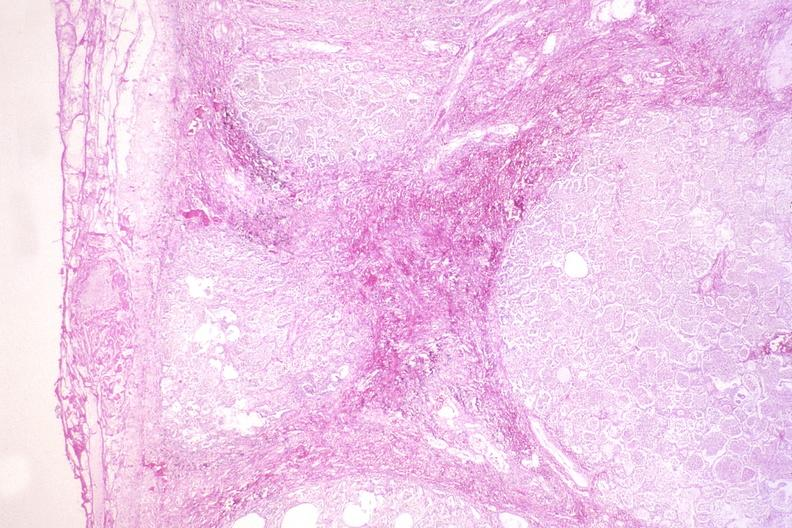what does this image show?
Answer the question using a single word or phrase. Kaposis 's sarcoma in the lung 